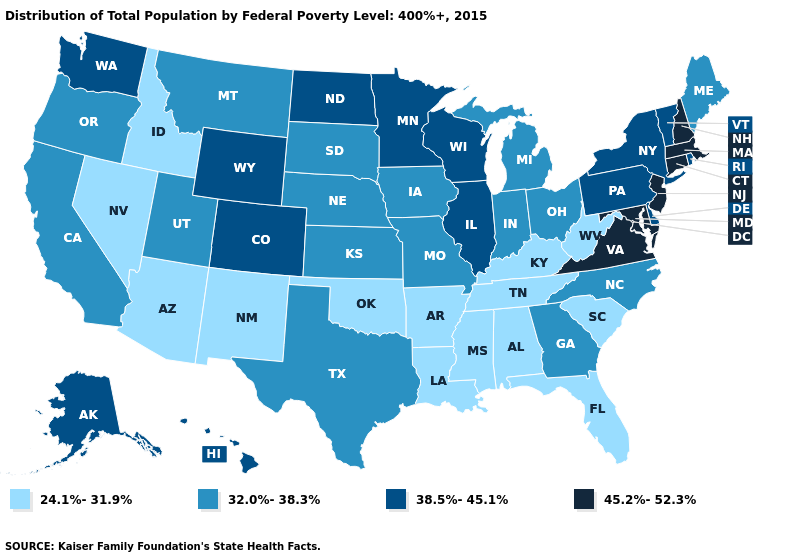Name the states that have a value in the range 45.2%-52.3%?
Be succinct. Connecticut, Maryland, Massachusetts, New Hampshire, New Jersey, Virginia. How many symbols are there in the legend?
Concise answer only. 4. How many symbols are there in the legend?
Concise answer only. 4. What is the highest value in the USA?
Give a very brief answer. 45.2%-52.3%. Does Virginia have the highest value in the USA?
Give a very brief answer. Yes. Does Georgia have the lowest value in the South?
Concise answer only. No. Name the states that have a value in the range 24.1%-31.9%?
Quick response, please. Alabama, Arizona, Arkansas, Florida, Idaho, Kentucky, Louisiana, Mississippi, Nevada, New Mexico, Oklahoma, South Carolina, Tennessee, West Virginia. Name the states that have a value in the range 32.0%-38.3%?
Concise answer only. California, Georgia, Indiana, Iowa, Kansas, Maine, Michigan, Missouri, Montana, Nebraska, North Carolina, Ohio, Oregon, South Dakota, Texas, Utah. Name the states that have a value in the range 45.2%-52.3%?
Keep it brief. Connecticut, Maryland, Massachusetts, New Hampshire, New Jersey, Virginia. Among the states that border Oklahoma , which have the highest value?
Quick response, please. Colorado. Name the states that have a value in the range 38.5%-45.1%?
Concise answer only. Alaska, Colorado, Delaware, Hawaii, Illinois, Minnesota, New York, North Dakota, Pennsylvania, Rhode Island, Vermont, Washington, Wisconsin, Wyoming. What is the value of New Hampshire?
Short answer required. 45.2%-52.3%. Among the states that border Delaware , does Pennsylvania have the lowest value?
Short answer required. Yes. Does the first symbol in the legend represent the smallest category?
Answer briefly. Yes. What is the lowest value in states that border Oklahoma?
Quick response, please. 24.1%-31.9%. 